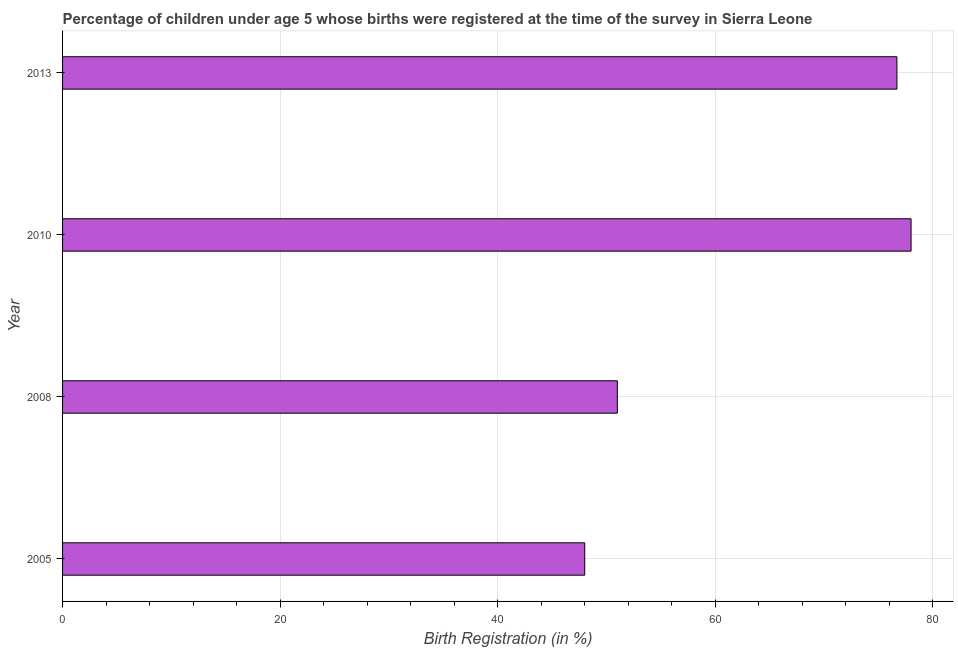What is the title of the graph?
Provide a short and direct response. Percentage of children under age 5 whose births were registered at the time of the survey in Sierra Leone. What is the label or title of the X-axis?
Give a very brief answer. Birth Registration (in %). What is the label or title of the Y-axis?
Ensure brevity in your answer.  Year. What is the birth registration in 2013?
Keep it short and to the point. 76.7. Across all years, what is the minimum birth registration?
Your response must be concise. 48. In which year was the birth registration minimum?
Ensure brevity in your answer.  2005. What is the sum of the birth registration?
Offer a terse response. 253.7. What is the average birth registration per year?
Your answer should be very brief. 63.42. What is the median birth registration?
Provide a succinct answer. 63.85. In how many years, is the birth registration greater than 64 %?
Give a very brief answer. 2. Do a majority of the years between 2008 and 2005 (inclusive) have birth registration greater than 52 %?
Provide a short and direct response. No. What is the ratio of the birth registration in 2005 to that in 2008?
Your answer should be compact. 0.94. Is the birth registration in 2005 less than that in 2008?
Offer a very short reply. Yes. In how many years, is the birth registration greater than the average birth registration taken over all years?
Ensure brevity in your answer.  2. How many bars are there?
Offer a very short reply. 4. How many years are there in the graph?
Make the answer very short. 4. What is the difference between two consecutive major ticks on the X-axis?
Your answer should be very brief. 20. Are the values on the major ticks of X-axis written in scientific E-notation?
Give a very brief answer. No. What is the Birth Registration (in %) of 2008?
Keep it short and to the point. 51. What is the Birth Registration (in %) in 2010?
Your response must be concise. 78. What is the Birth Registration (in %) in 2013?
Give a very brief answer. 76.7. What is the difference between the Birth Registration (in %) in 2005 and 2013?
Provide a short and direct response. -28.7. What is the difference between the Birth Registration (in %) in 2008 and 2010?
Provide a succinct answer. -27. What is the difference between the Birth Registration (in %) in 2008 and 2013?
Your answer should be very brief. -25.7. What is the difference between the Birth Registration (in %) in 2010 and 2013?
Your answer should be compact. 1.3. What is the ratio of the Birth Registration (in %) in 2005 to that in 2008?
Your answer should be very brief. 0.94. What is the ratio of the Birth Registration (in %) in 2005 to that in 2010?
Offer a very short reply. 0.61. What is the ratio of the Birth Registration (in %) in 2005 to that in 2013?
Give a very brief answer. 0.63. What is the ratio of the Birth Registration (in %) in 2008 to that in 2010?
Give a very brief answer. 0.65. What is the ratio of the Birth Registration (in %) in 2008 to that in 2013?
Ensure brevity in your answer.  0.67. 